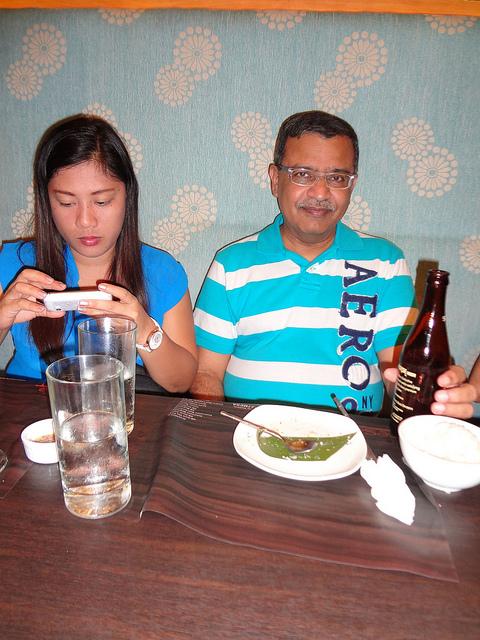Does the mat's color and wrinkle against the similarly colored table create a  trompe-l'oeil?
Write a very short answer. Yes. Is this woman interested in this photo?
Keep it brief. No. What is the man drinking?
Quick response, please. Beer. 